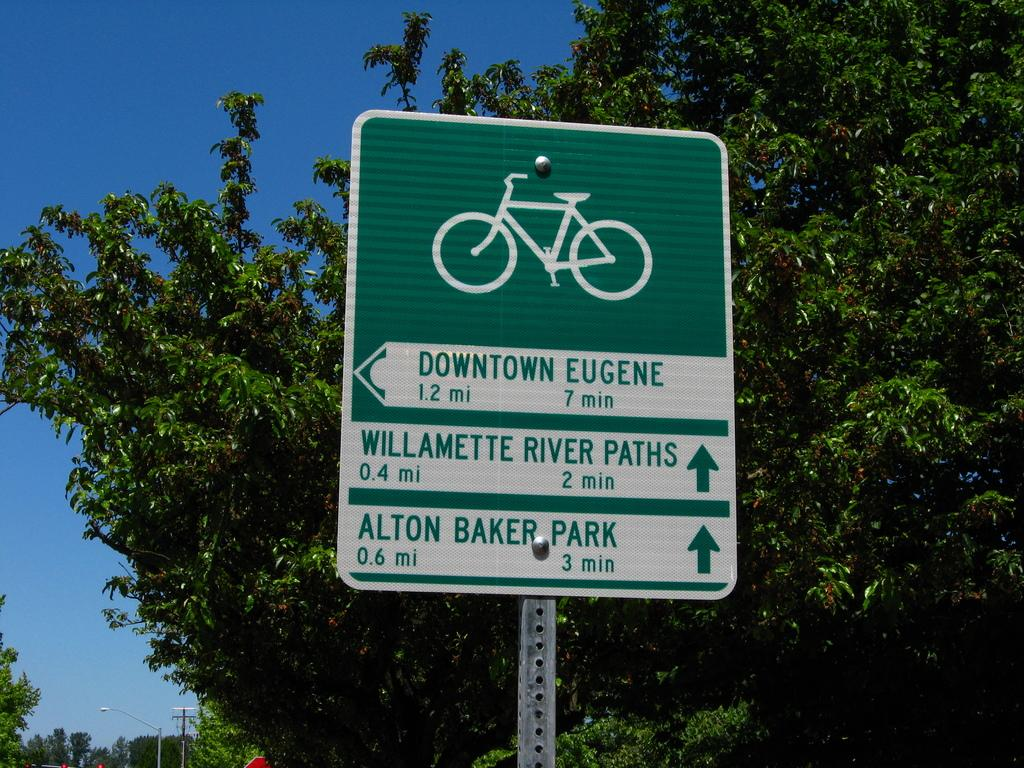What is the main object in the middle of the image? There is a caution board in the middle of the image. What is the purpose of the caution board? The caution board is likely meant to warn or inform people about potential hazards or safety precautions. What can be seen behind the caution board? There are plants behind the caution board. What is visible above the caution board and plants? The sky is visible above the caution board and plants. What type of cloud can be seen in the image? There is no cloud visible in the image; only the sky is visible above the caution board and plants. What kind of music is the band playing in the image? There is no band present in the image. How many pears are on the caution board in the image? There are no pears present in the image. 